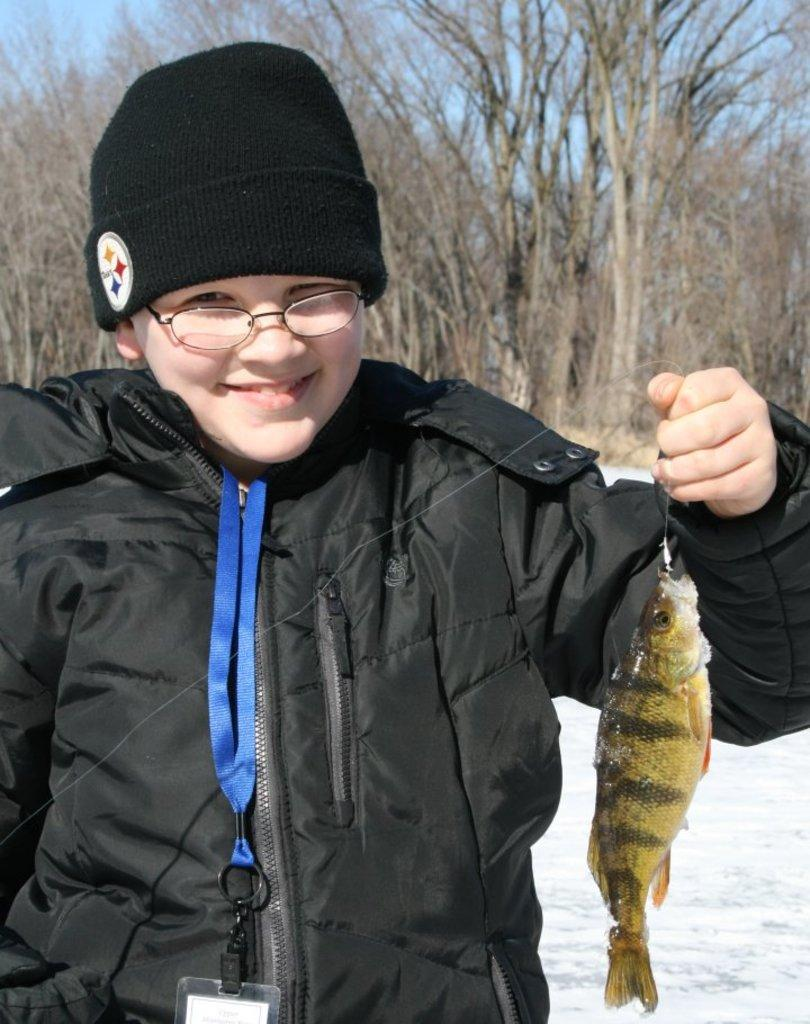What is the person in the image wearing? The person is wearing a black jacket, spectacles, and a black cap. What accessory is the person wearing that might indicate their identity? The person is wearing an identity card. What is the person holding in the image? The person is holding a fish. What can be seen in the background of the image? There is snow, trees, and the sky visible in the background of the image. What type of scarf is the person wearing in the image? There is no scarf visible in the image; the person is wearing a black jacket, spectacles, and a black cap. Can you hear the person whistling in the image? There is no indication of sound or whistling in the image; it is a still photograph. 